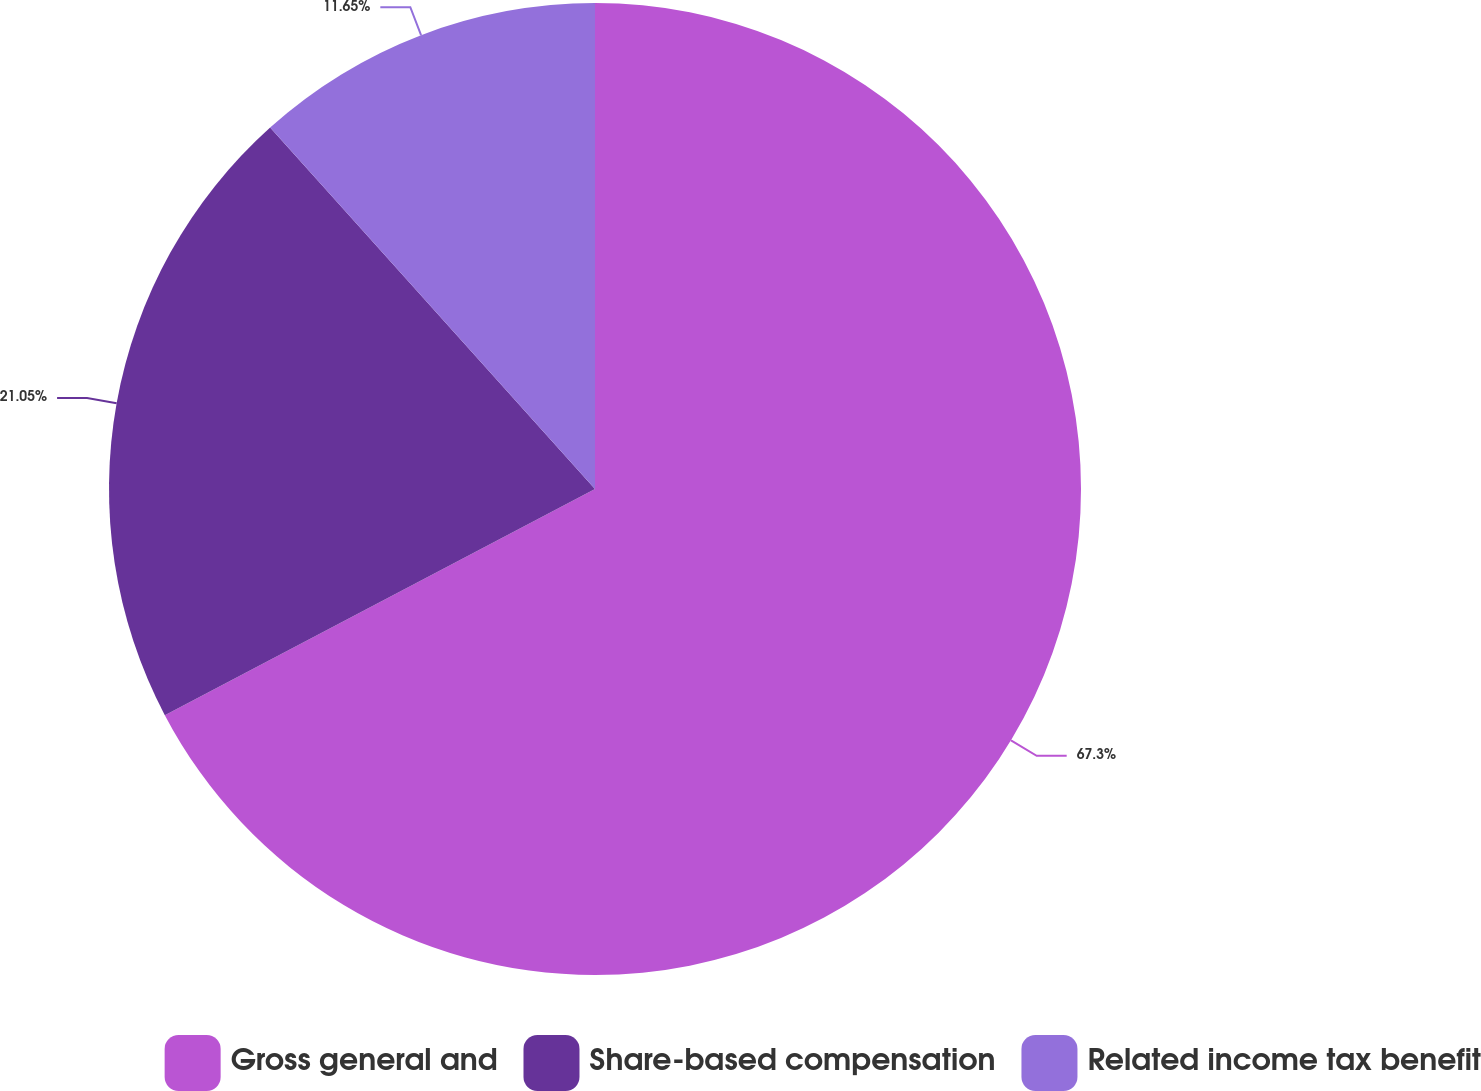Convert chart to OTSL. <chart><loc_0><loc_0><loc_500><loc_500><pie_chart><fcel>Gross general and<fcel>Share-based compensation<fcel>Related income tax benefit<nl><fcel>67.29%<fcel>21.05%<fcel>11.65%<nl></chart> 